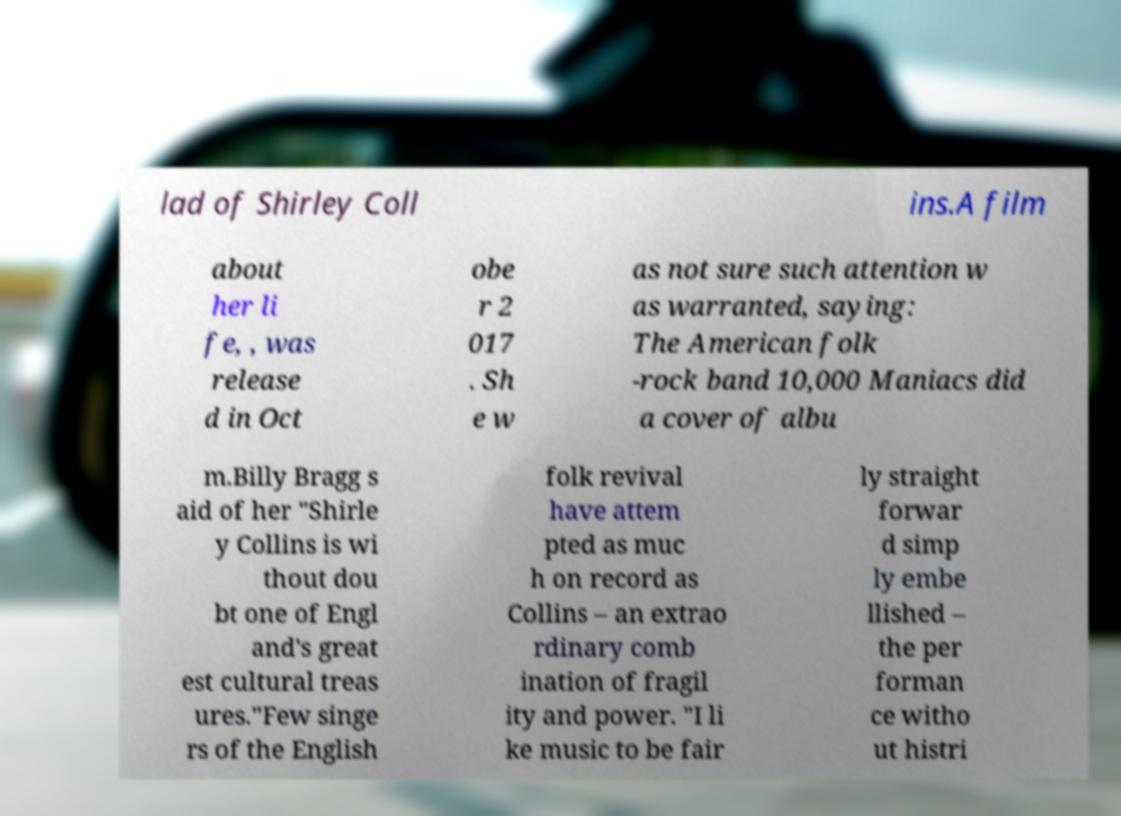Please read and relay the text visible in this image. What does it say? lad of Shirley Coll ins.A film about her li fe, , was release d in Oct obe r 2 017 . Sh e w as not sure such attention w as warranted, saying: The American folk -rock band 10,000 Maniacs did a cover of albu m.Billy Bragg s aid of her "Shirle y Collins is wi thout dou bt one of Engl and's great est cultural treas ures."Few singe rs of the English folk revival have attem pted as muc h on record as Collins – an extrao rdinary comb ination of fragil ity and power. "I li ke music to be fair ly straight forwar d simp ly embe llished – the per forman ce witho ut histri 